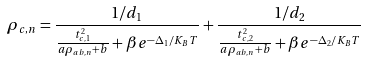Convert formula to latex. <formula><loc_0><loc_0><loc_500><loc_500>\rho _ { c , n } = \frac { 1 / d _ { 1 } } { \frac { t _ { c , 1 } ^ { 2 } } { a \rho _ { a b , n } + b } + \beta e ^ { - \Delta _ { 1 } / K _ { B } T } } + \frac { 1 / d _ { 2 } } { \frac { t _ { c , 2 } ^ { 2 } } { a \rho _ { a b , n } + b } + \beta e ^ { - \Delta _ { 2 } / K _ { B } T } }</formula> 